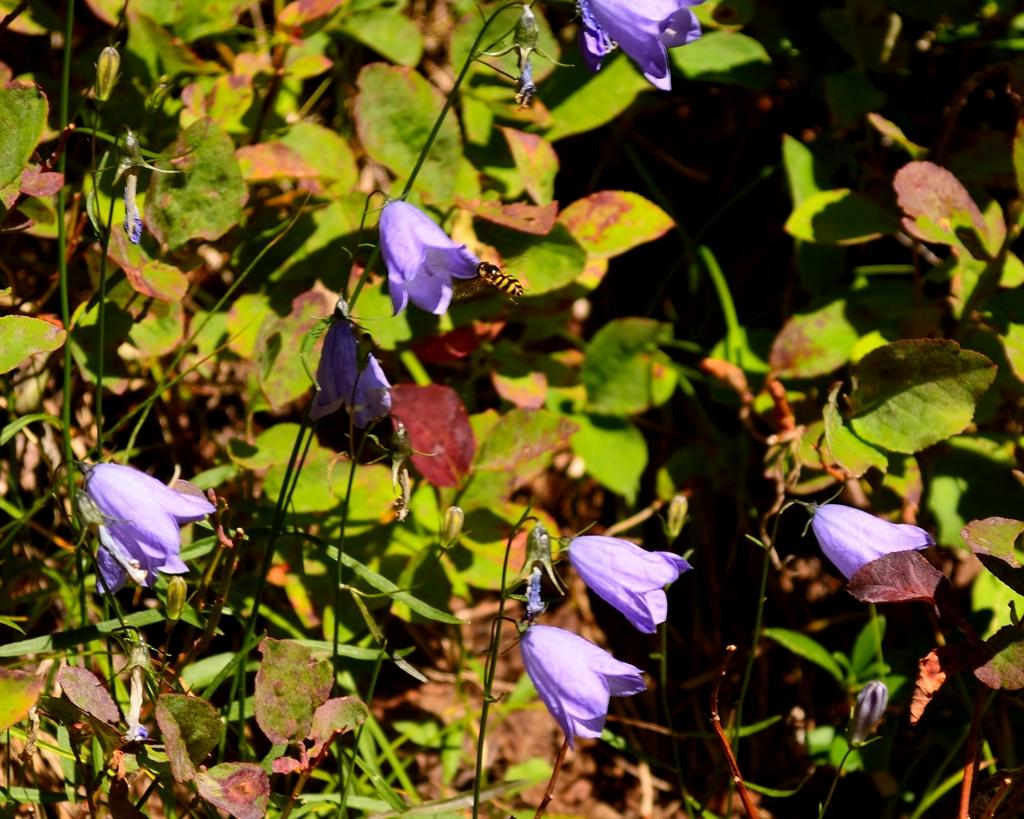What type of plants can be seen in the image? There are flower plants in the image. What color are the flowers on these plants? The flowers are purple in color. How many icicles are hanging from the lizards in the image? There are no icicles or lizards present in the image; it features flower plants with purple flowers. 